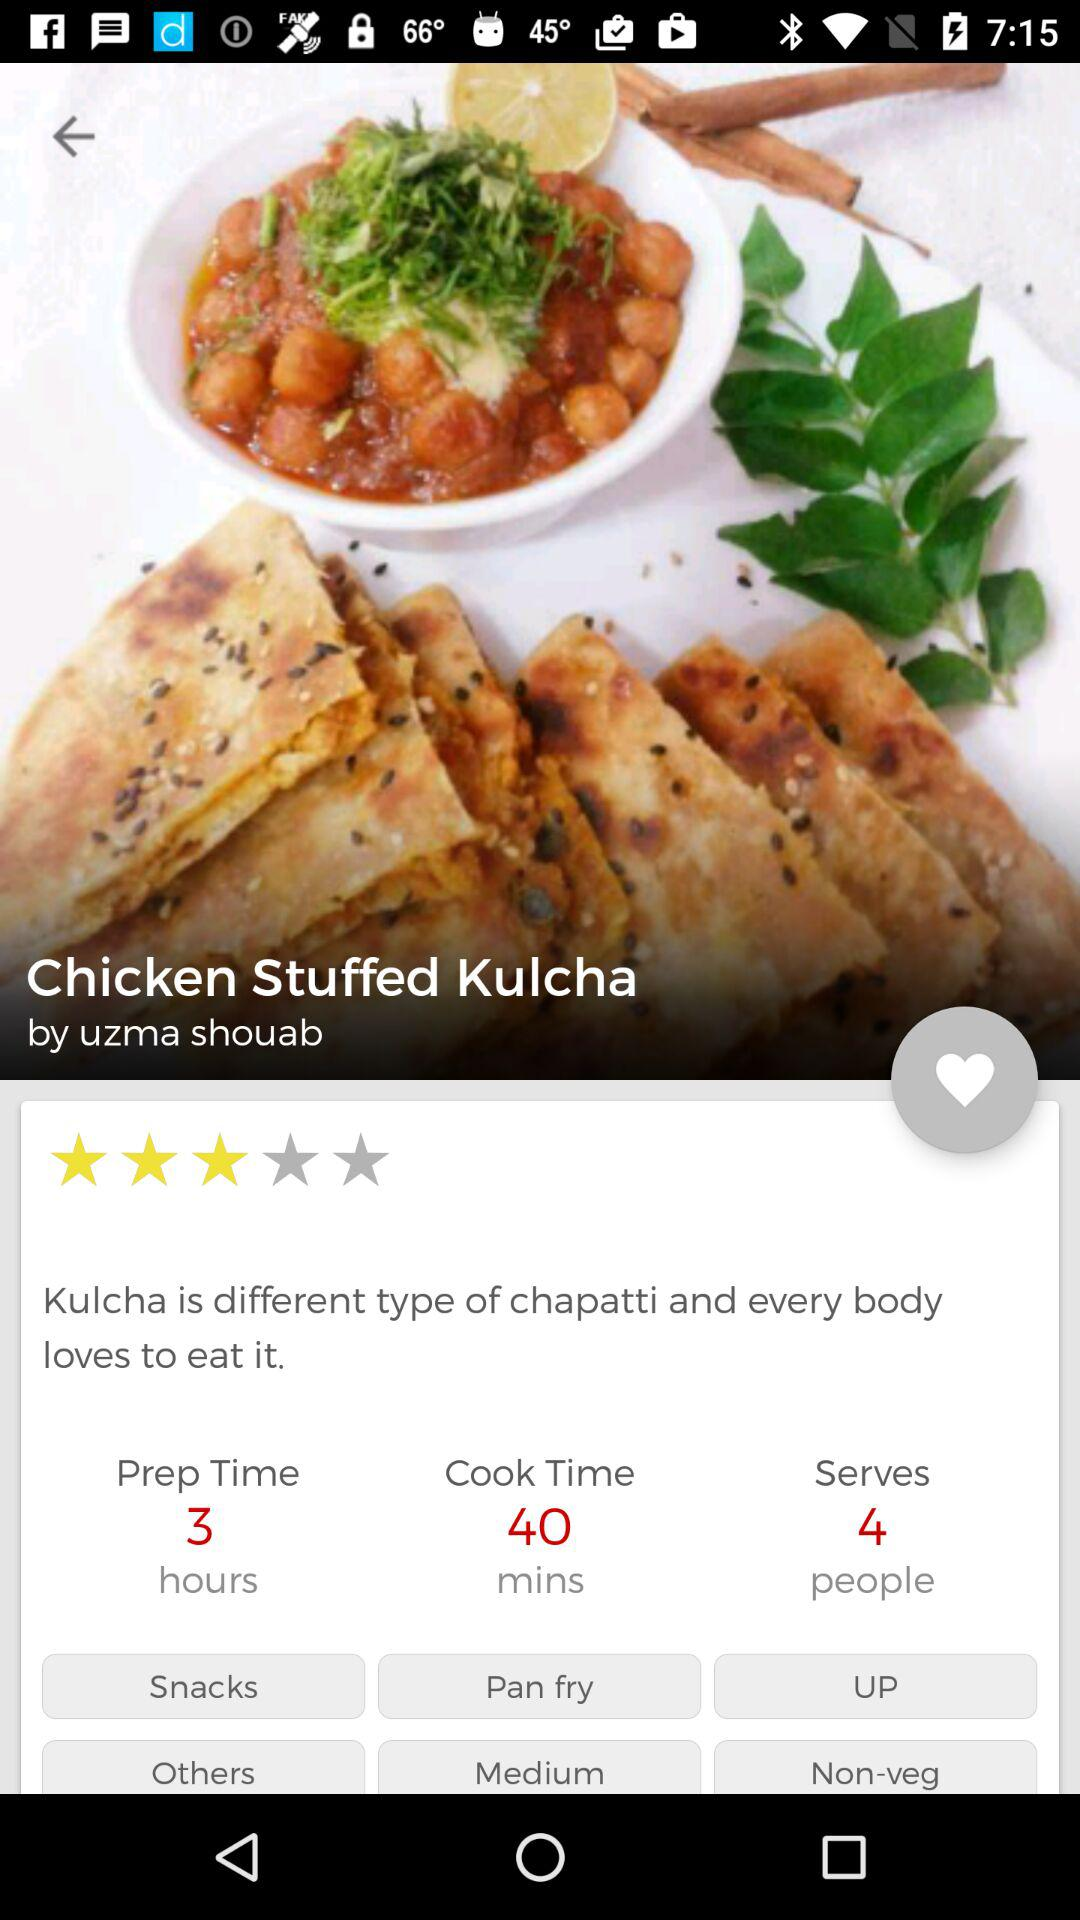What is the preparation time for the dish? The preparation time for the dish is 3 hours. 